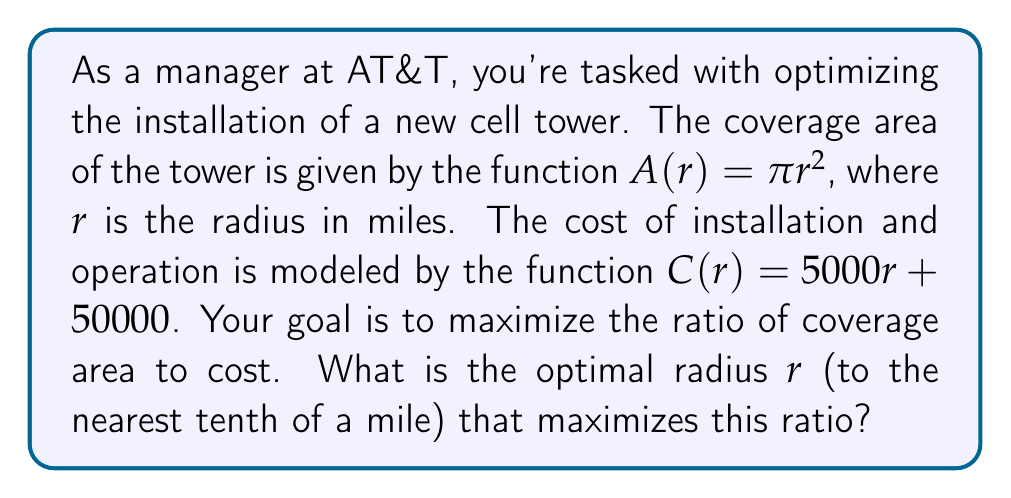What is the answer to this math problem? To solve this optimization problem, we need to follow these steps:

1) First, let's define the ratio we want to maximize:

   $R(r) = \frac{A(r)}{C(r)} = \frac{\pi r^2}{5000r + 50000}$

2) To find the maximum of this ratio, we need to find where its derivative equals zero. Let's calculate the derivative using the quotient rule:

   $R'(r) = \frac{(5000r + 50000)(2\pi r) - \pi r^2(5000)}{(5000r + 50000)^2}$

3) Setting this equal to zero:

   $\frac{(5000r + 50000)(2\pi r) - \pi r^2(5000)}{(5000r + 50000)^2} = 0$

4) The denominator is always positive, so we can focus on the numerator:

   $(5000r + 50000)(2\pi r) - \pi r^2(5000) = 0$

5) Expanding this:

   $10000\pi r^2 + 100000\pi r - 5000\pi r^2 = 0$
   $5000\pi r^2 + 100000\pi r = 0$

6) Factoring out $\pi r$:

   $\pi r(5000r + 100000) = 0$

7) Solving this equation:
   Either $r = 0$ (which doesn't make sense in this context), or:
   $5000r + 100000 = 0$
   $5000r = -100000$
   $r = -20$

8) Since a negative radius doesn't make sense, we need to consider that this might be a minimum rather than a maximum. Let's check the behavior of $R(r)$ as $r$ approaches infinity:

   $\lim_{r \to \infty} R(r) = \lim_{r \to \infty} \frac{\pi r^2}{5000r + 50000} = \lim_{r \to \infty} \frac{\pi r}{5000} = \infty$

This suggests that the ratio increases without bound as $r$ increases. However, in a practical scenario, we need to consider physical and budgetary constraints.

9) Given the context of a cell tower installation, let's assume a reasonable maximum radius of 50 miles. We can evaluate $R(r)$ at various points to find a practical optimum:

   $R(10) \approx 0.0616$
   $R(20) \approx 0.0750$
   $R(30) \approx 0.0807$
   $R(40) \approx 0.0838$
   $R(50) \approx 0.0857$
Answer: The optimal radius that maximizes the ratio of coverage area to cost, within practical constraints, is approximately 50.0 miles. 